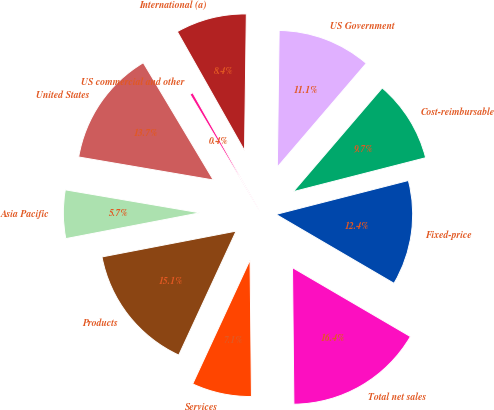Convert chart to OTSL. <chart><loc_0><loc_0><loc_500><loc_500><pie_chart><fcel>Products<fcel>Services<fcel>Total net sales<fcel>Fixed-price<fcel>Cost-reimbursable<fcel>US Government<fcel>International (a)<fcel>US commercial and other<fcel>United States<fcel>Asia Pacific<nl><fcel>15.08%<fcel>7.06%<fcel>16.42%<fcel>12.41%<fcel>9.73%<fcel>11.07%<fcel>8.4%<fcel>0.38%<fcel>13.74%<fcel>5.72%<nl></chart> 